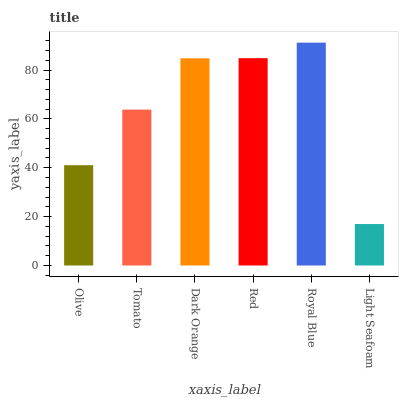Is Light Seafoam the minimum?
Answer yes or no. Yes. Is Royal Blue the maximum?
Answer yes or no. Yes. Is Tomato the minimum?
Answer yes or no. No. Is Tomato the maximum?
Answer yes or no. No. Is Tomato greater than Olive?
Answer yes or no. Yes. Is Olive less than Tomato?
Answer yes or no. Yes. Is Olive greater than Tomato?
Answer yes or no. No. Is Tomato less than Olive?
Answer yes or no. No. Is Dark Orange the high median?
Answer yes or no. Yes. Is Tomato the low median?
Answer yes or no. Yes. Is Tomato the high median?
Answer yes or no. No. Is Olive the low median?
Answer yes or no. No. 